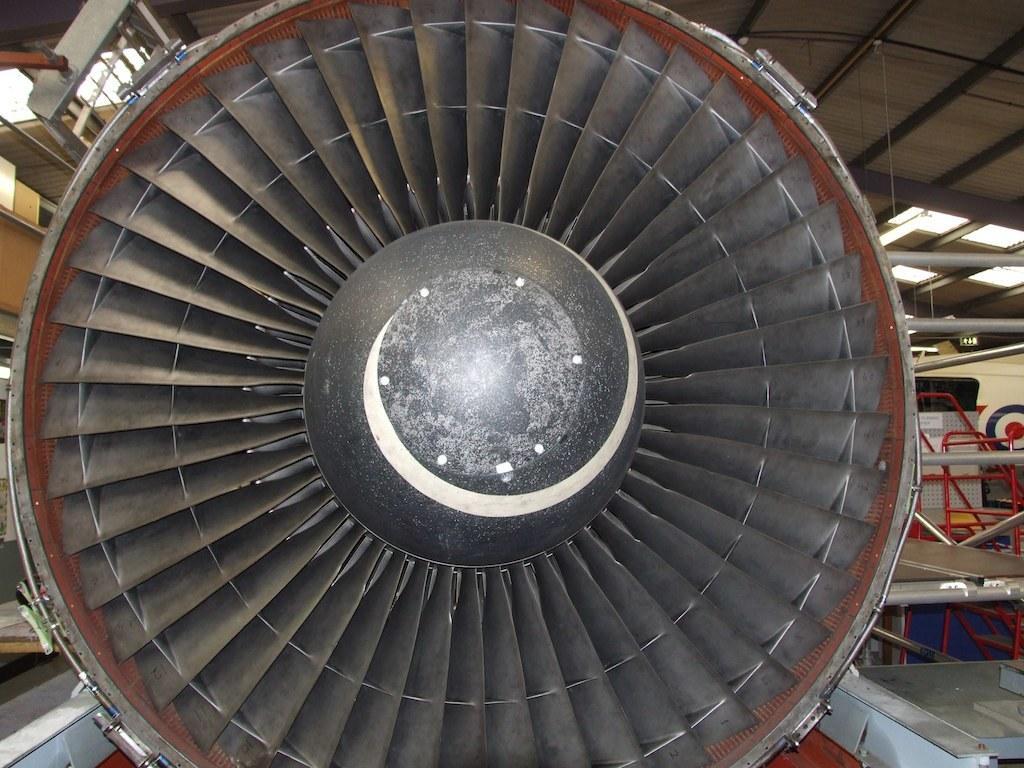Can you describe this image briefly? In this image I can see an engine. On both sides of an engine I can see some objects. These are inside the shed. 